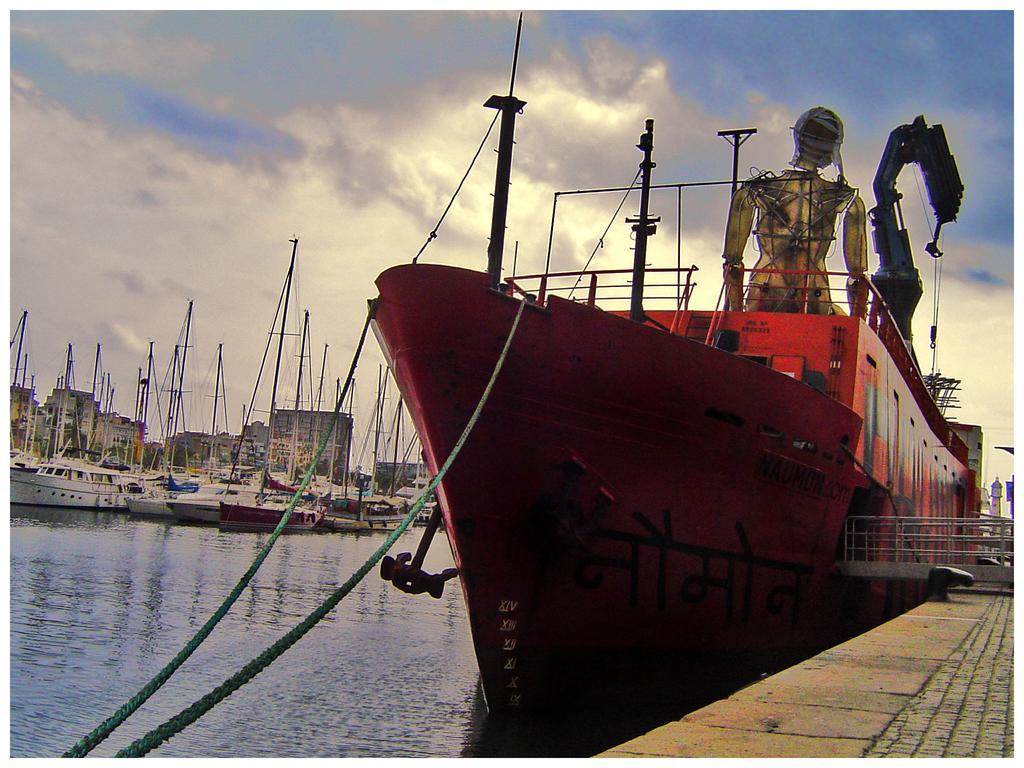In one or two sentences, can you explain what this image depicts? In this image I can see few boats floating on the water. At the top I can see clouds in the sky. 